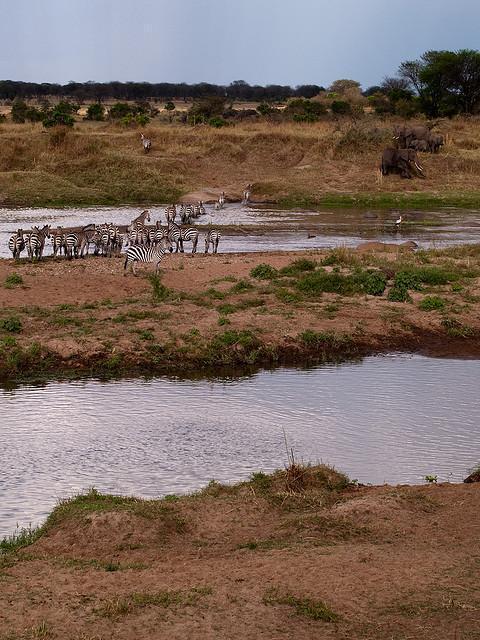How many types of animals are there?
Give a very brief answer. 2. 